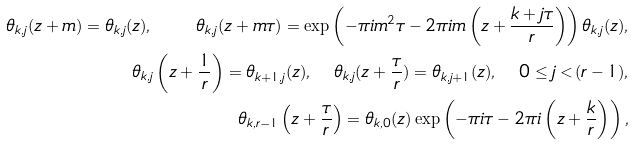<formula> <loc_0><loc_0><loc_500><loc_500>\theta _ { k , j } ( z + m ) = \theta _ { k , j } ( z ) , \quad \theta _ { k , j } ( z + m \tau ) = \exp \left ( - \pi i m ^ { 2 } \tau - 2 \pi i m \left ( z + \frac { k + j \tau } { r } \right ) \right ) \theta _ { k , j } ( z ) , \\ \theta _ { k , j } \left ( z + { \frac { 1 } { r } } \right ) = \theta _ { k + 1 , j } ( z ) , \quad \theta _ { k , j } ( z + \frac { \tau } { r } ) = \theta _ { k , j + 1 } ( z ) , \quad 0 \leq j < ( r - 1 ) , \\ \theta _ { k , r - 1 } \left ( z + \frac { \tau } { r } \right ) = \theta _ { k , 0 } ( z ) \exp \left ( - \pi i \tau - 2 \pi i \left ( z + \frac { k } { r } \right ) \right ) ,</formula> 